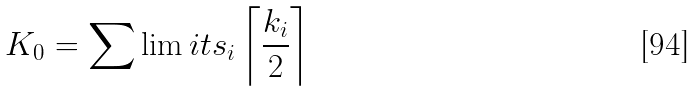<formula> <loc_0><loc_0><loc_500><loc_500>K _ { 0 } = \sum \lim i t s _ { i } \left \lceil { \frac { k _ { i } } { 2 } } \right \rceil</formula> 